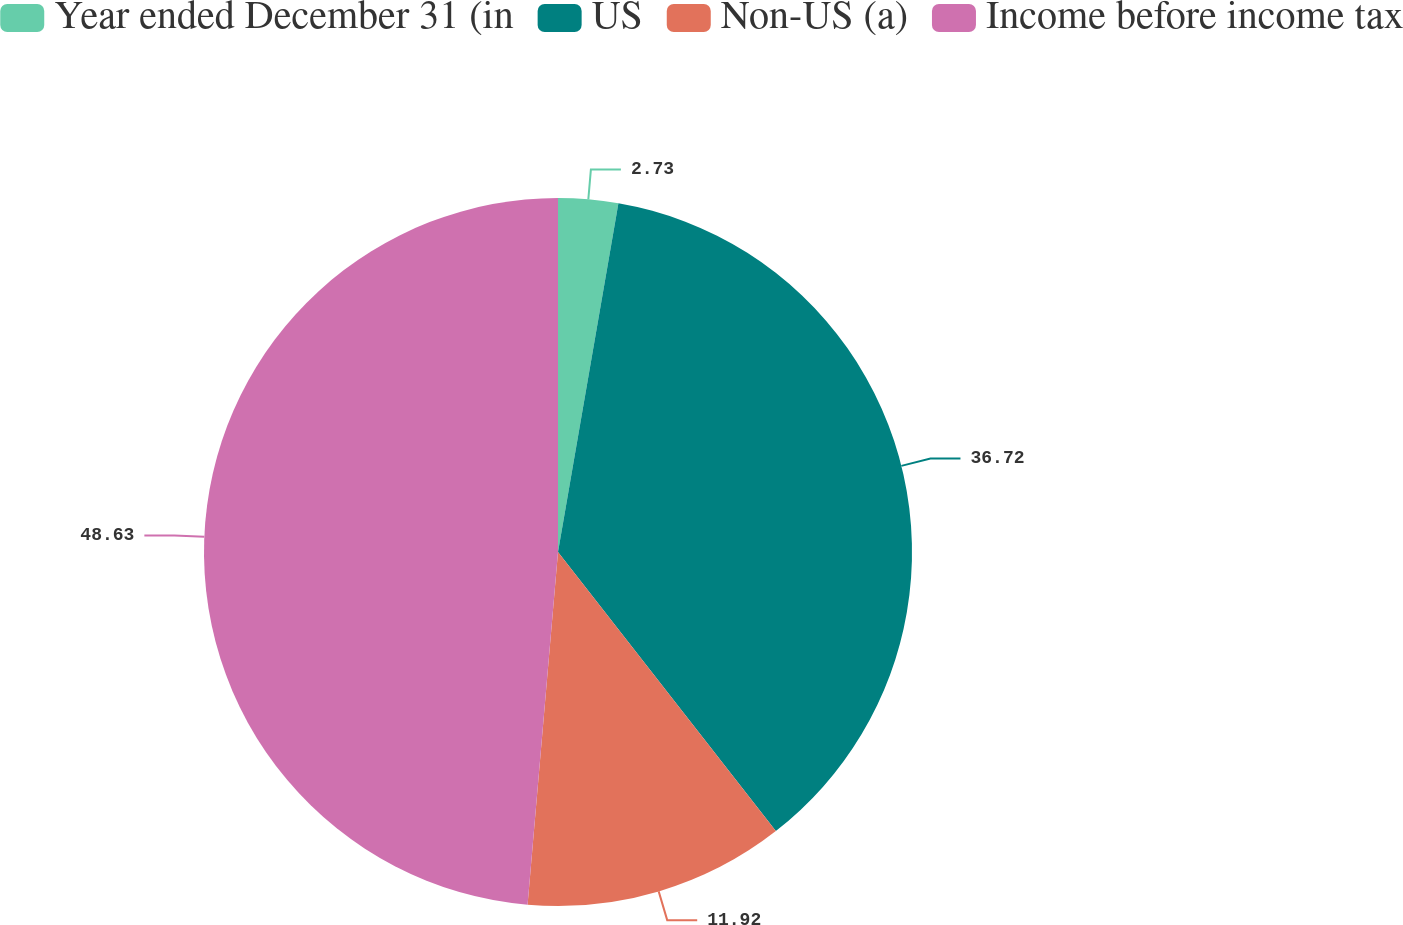Convert chart to OTSL. <chart><loc_0><loc_0><loc_500><loc_500><pie_chart><fcel>Year ended December 31 (in<fcel>US<fcel>Non-US (a)<fcel>Income before income tax<nl><fcel>2.73%<fcel>36.72%<fcel>11.92%<fcel>48.63%<nl></chart> 